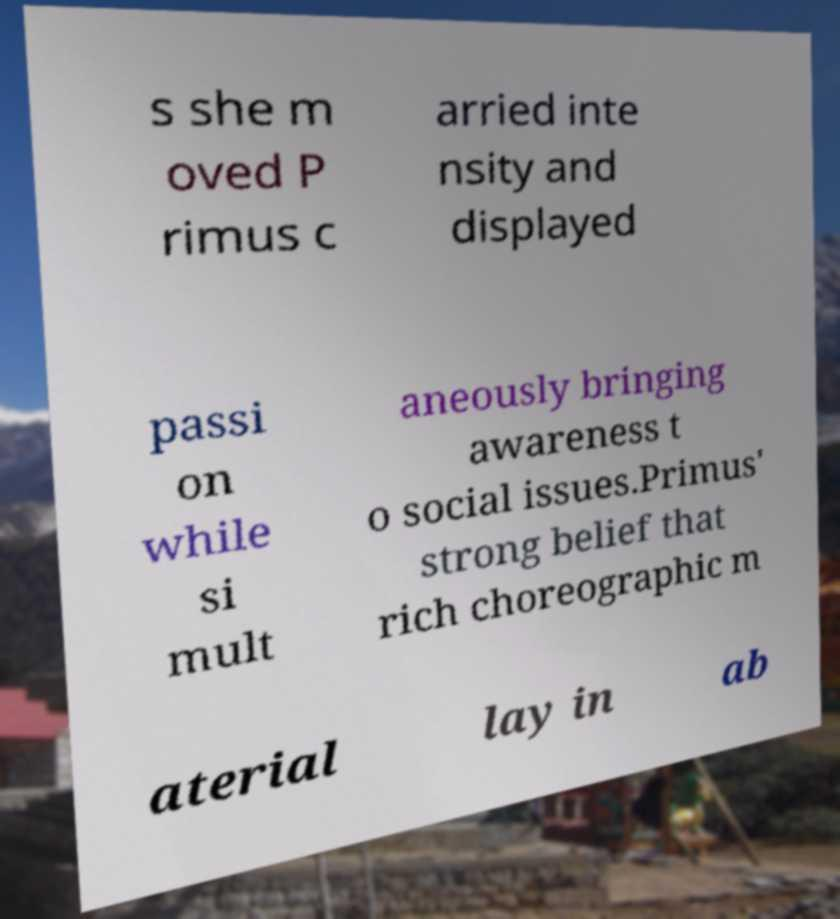Can you accurately transcribe the text from the provided image for me? s she m oved P rimus c arried inte nsity and displayed passi on while si mult aneously bringing awareness t o social issues.Primus' strong belief that rich choreographic m aterial lay in ab 